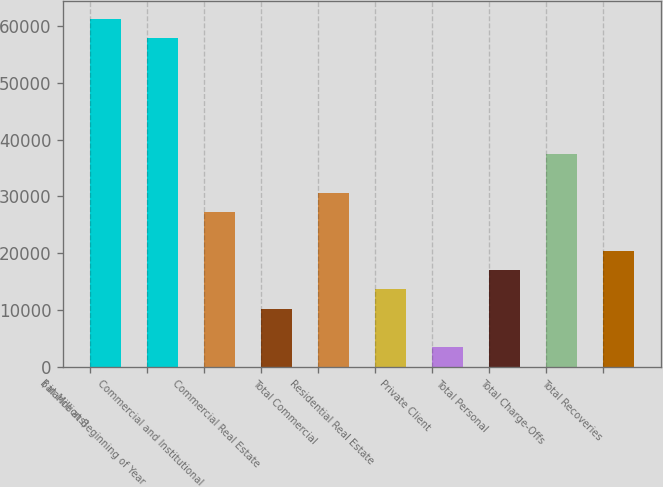Convert chart to OTSL. <chart><loc_0><loc_0><loc_500><loc_500><bar_chart><fcel>( in Millions)<fcel>Balance at Beginning of Year<fcel>Commercial and Institutional<fcel>Commercial Real Estate<fcel>Total Commercial<fcel>Residential Real Estate<fcel>Private Client<fcel>Total Personal<fcel>Total Charge-Offs<fcel>Total Recoveries<nl><fcel>61278.3<fcel>57874<fcel>27234.8<fcel>10213.1<fcel>30639.2<fcel>13617.4<fcel>3404.39<fcel>17021.8<fcel>37447.9<fcel>20426.1<nl></chart> 